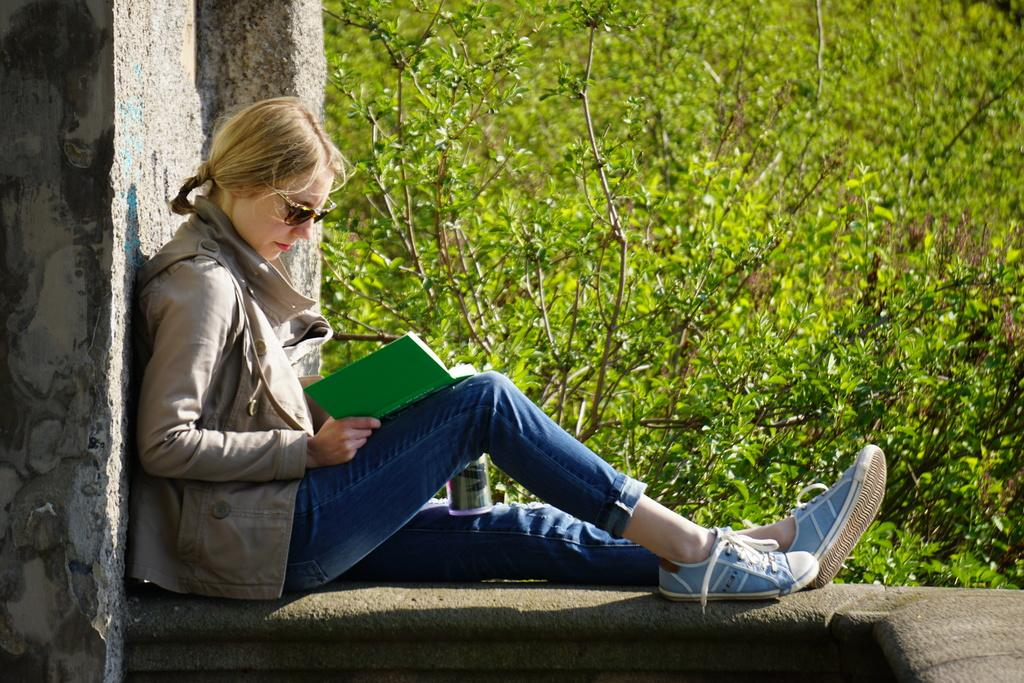Who is the main subject in the image? There is a woman in the image. What is the woman holding in the image? The woman is holding a book. Where is the woman sitting in the image? The woman is sitting on a wall. What else is on the woman's lap in the image? There is a bottle on the woman's lap. What can be seen in the background of the image? There are trees in the background of the image. What type of glass is the woman drinking from in the image? There is no glass present in the image; the woman is holding a bottle. 